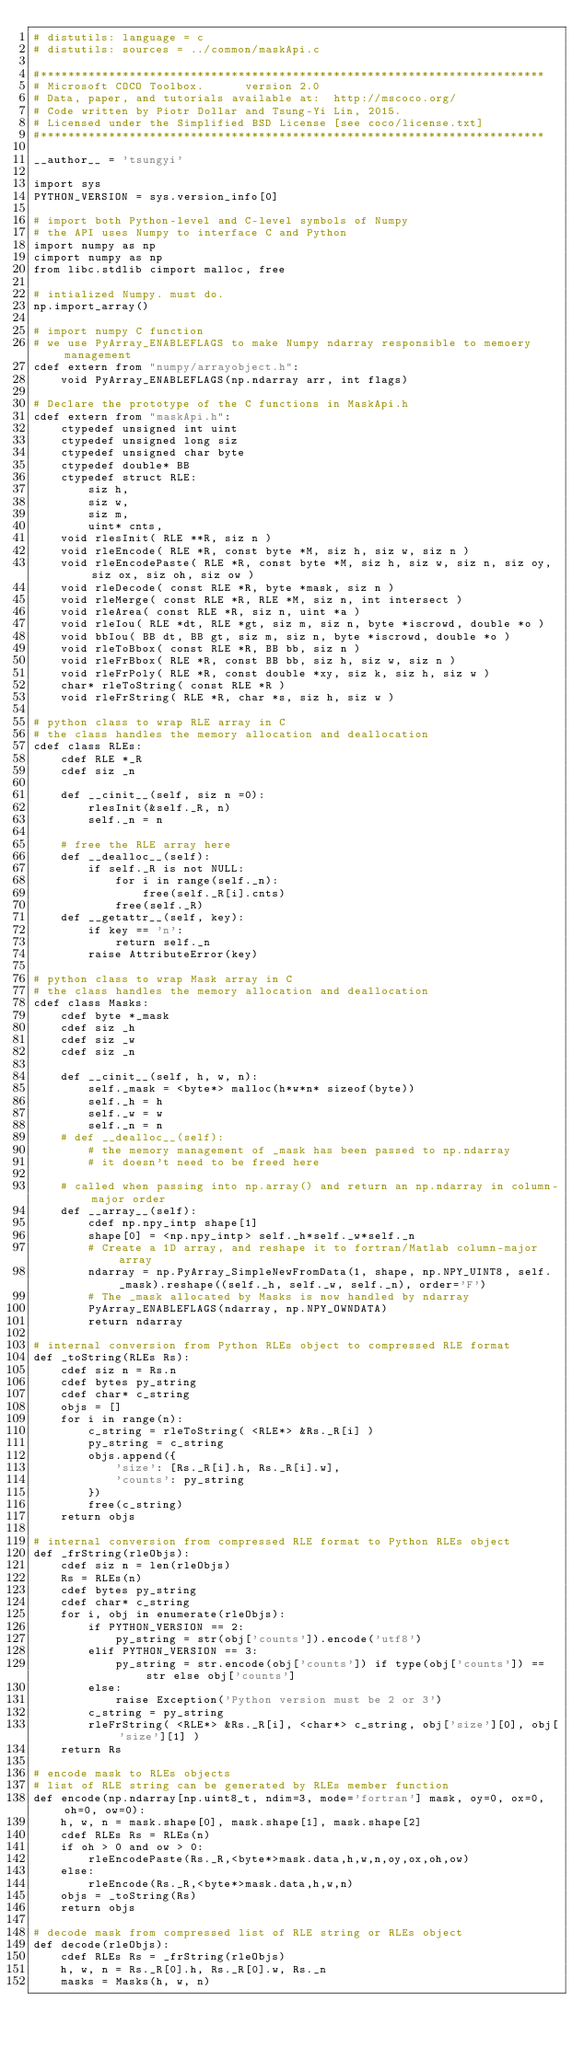Convert code to text. <code><loc_0><loc_0><loc_500><loc_500><_Cython_># distutils: language = c
# distutils: sources = ../common/maskApi.c

#**************************************************************************
# Microsoft COCO Toolbox.      version 2.0
# Data, paper, and tutorials available at:  http://mscoco.org/
# Code written by Piotr Dollar and Tsung-Yi Lin, 2015.
# Licensed under the Simplified BSD License [see coco/license.txt]
#**************************************************************************

__author__ = 'tsungyi'

import sys
PYTHON_VERSION = sys.version_info[0]

# import both Python-level and C-level symbols of Numpy
# the API uses Numpy to interface C and Python
import numpy as np
cimport numpy as np
from libc.stdlib cimport malloc, free

# intialized Numpy. must do.
np.import_array()

# import numpy C function
# we use PyArray_ENABLEFLAGS to make Numpy ndarray responsible to memoery management
cdef extern from "numpy/arrayobject.h":
    void PyArray_ENABLEFLAGS(np.ndarray arr, int flags)

# Declare the prototype of the C functions in MaskApi.h
cdef extern from "maskApi.h":
    ctypedef unsigned int uint
    ctypedef unsigned long siz
    ctypedef unsigned char byte
    ctypedef double* BB
    ctypedef struct RLE:
        siz h,
        siz w,
        siz m,
        uint* cnts,
    void rlesInit( RLE **R, siz n )
    void rleEncode( RLE *R, const byte *M, siz h, siz w, siz n )
    void rleEncodePaste( RLE *R, const byte *M, siz h, siz w, siz n, siz oy, siz ox, siz oh, siz ow )
    void rleDecode( const RLE *R, byte *mask, siz n )
    void rleMerge( const RLE *R, RLE *M, siz n, int intersect )
    void rleArea( const RLE *R, siz n, uint *a )
    void rleIou( RLE *dt, RLE *gt, siz m, siz n, byte *iscrowd, double *o )
    void bbIou( BB dt, BB gt, siz m, siz n, byte *iscrowd, double *o )
    void rleToBbox( const RLE *R, BB bb, siz n )
    void rleFrBbox( RLE *R, const BB bb, siz h, siz w, siz n )
    void rleFrPoly( RLE *R, const double *xy, siz k, siz h, siz w )
    char* rleToString( const RLE *R )
    void rleFrString( RLE *R, char *s, siz h, siz w )

# python class to wrap RLE array in C
# the class handles the memory allocation and deallocation
cdef class RLEs:
    cdef RLE *_R
    cdef siz _n

    def __cinit__(self, siz n =0):
        rlesInit(&self._R, n)
        self._n = n

    # free the RLE array here
    def __dealloc__(self):
        if self._R is not NULL:
            for i in range(self._n):
                free(self._R[i].cnts)
            free(self._R)
    def __getattr__(self, key):
        if key == 'n':
            return self._n
        raise AttributeError(key)

# python class to wrap Mask array in C
# the class handles the memory allocation and deallocation
cdef class Masks:
    cdef byte *_mask
    cdef siz _h
    cdef siz _w
    cdef siz _n

    def __cinit__(self, h, w, n):
        self._mask = <byte*> malloc(h*w*n* sizeof(byte))
        self._h = h
        self._w = w
        self._n = n
    # def __dealloc__(self):
        # the memory management of _mask has been passed to np.ndarray
        # it doesn't need to be freed here

    # called when passing into np.array() and return an np.ndarray in column-major order
    def __array__(self):
        cdef np.npy_intp shape[1]
        shape[0] = <np.npy_intp> self._h*self._w*self._n
        # Create a 1D array, and reshape it to fortran/Matlab column-major array
        ndarray = np.PyArray_SimpleNewFromData(1, shape, np.NPY_UINT8, self._mask).reshape((self._h, self._w, self._n), order='F')
        # The _mask allocated by Masks is now handled by ndarray
        PyArray_ENABLEFLAGS(ndarray, np.NPY_OWNDATA)
        return ndarray

# internal conversion from Python RLEs object to compressed RLE format
def _toString(RLEs Rs):
    cdef siz n = Rs.n
    cdef bytes py_string
    cdef char* c_string
    objs = []
    for i in range(n):
        c_string = rleToString( <RLE*> &Rs._R[i] )
        py_string = c_string
        objs.append({
            'size': [Rs._R[i].h, Rs._R[i].w],
            'counts': py_string
        })
        free(c_string)
    return objs

# internal conversion from compressed RLE format to Python RLEs object
def _frString(rleObjs):
    cdef siz n = len(rleObjs)
    Rs = RLEs(n)
    cdef bytes py_string
    cdef char* c_string
    for i, obj in enumerate(rleObjs):
        if PYTHON_VERSION == 2:
            py_string = str(obj['counts']).encode('utf8')
        elif PYTHON_VERSION == 3:
            py_string = str.encode(obj['counts']) if type(obj['counts']) == str else obj['counts']
        else:
            raise Exception('Python version must be 2 or 3')
        c_string = py_string
        rleFrString( <RLE*> &Rs._R[i], <char*> c_string, obj['size'][0], obj['size'][1] )
    return Rs

# encode mask to RLEs objects
# list of RLE string can be generated by RLEs member function
def encode(np.ndarray[np.uint8_t, ndim=3, mode='fortran'] mask, oy=0, ox=0, oh=0, ow=0):
    h, w, n = mask.shape[0], mask.shape[1], mask.shape[2]
    cdef RLEs Rs = RLEs(n)
    if oh > 0 and ow > 0:
        rleEncodePaste(Rs._R,<byte*>mask.data,h,w,n,oy,ox,oh,ow)
    else:
        rleEncode(Rs._R,<byte*>mask.data,h,w,n)
    objs = _toString(Rs)
    return objs

# decode mask from compressed list of RLE string or RLEs object
def decode(rleObjs):
    cdef RLEs Rs = _frString(rleObjs)
    h, w, n = Rs._R[0].h, Rs._R[0].w, Rs._n
    masks = Masks(h, w, n)</code> 